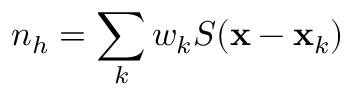Convert formula to latex. <formula><loc_0><loc_0><loc_500><loc_500>n _ { h } = \sum _ { k } w _ { k } S ( { \mathbf x } - { \mathbf x } _ { k } )</formula> 